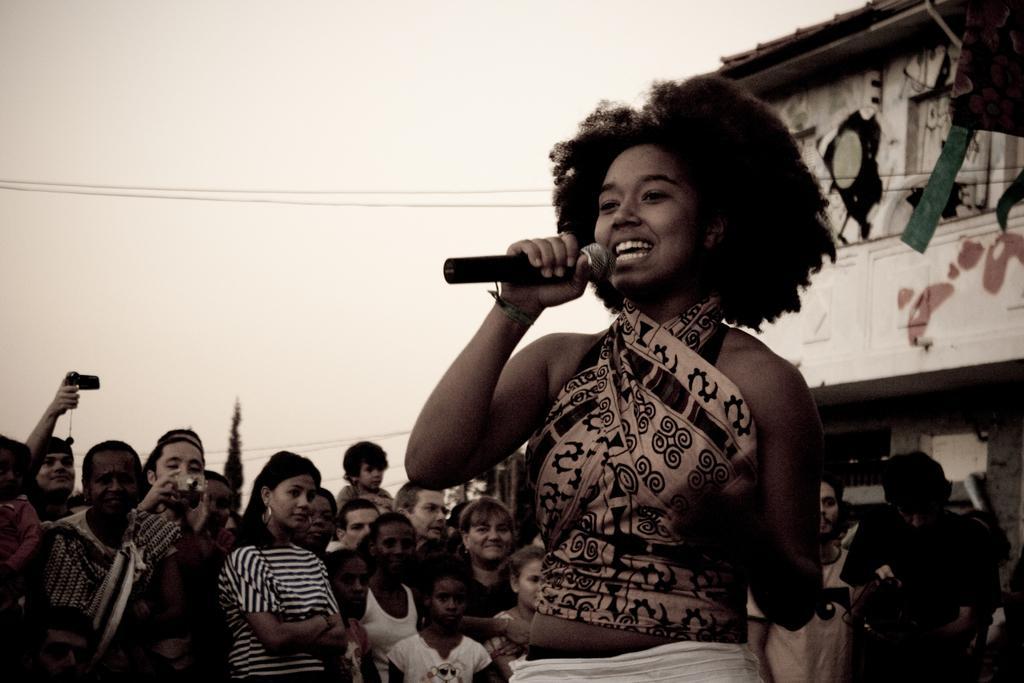In one or two sentences, can you explain what this image depicts? In the center we can see lady she is smiling and holding microphone. And back of her we can see group of persons were standing ,they were audience. And few persons were holding camera and we can see sky and some house. 